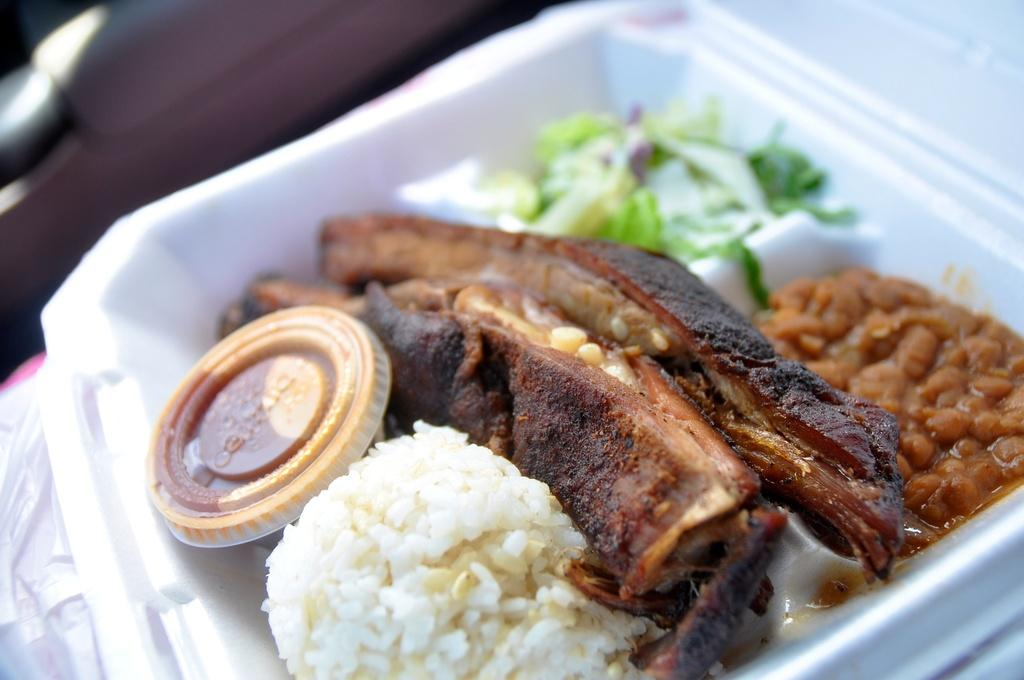What is the main object in the image? There is a white color box in the image. What is inside the box? The food items are in the box. Can you describe the colors of the food items? The food has colors such as brown, black, green, and white. How is the background of the image depicted? The background of the image is blurred. What type of yam is being massaged in the image? There is no yam or any indication of massaging in the image. 